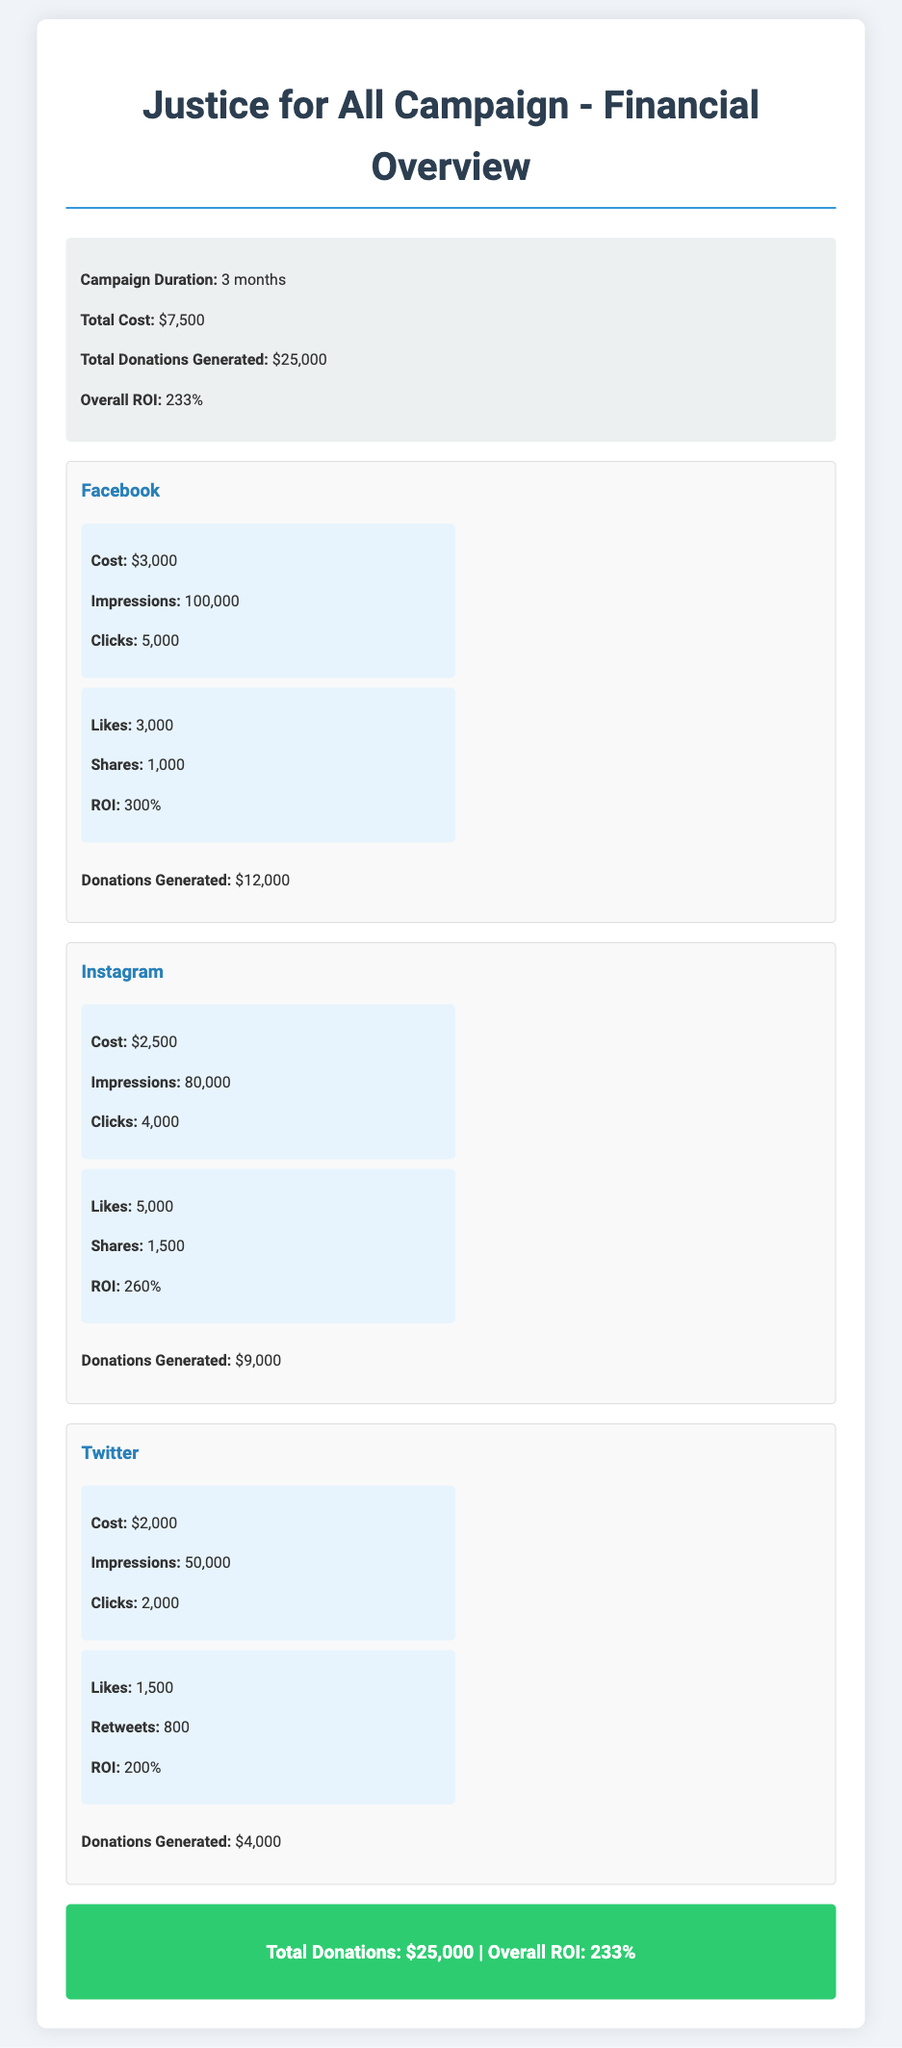What is the total cost of the campaign? The total cost is listed in the summary section of the document as $7,500.
Answer: $7,500 What was the total amount of donations generated? The total donations generated are provided in the summary section as $25,000.
Answer: $25,000 What is the ROI for the Facebook platform? The ROI for Facebook is stated in the metrics section specific to Facebook as 300%.
Answer: 300% How many impressions did the Instagram campaign receive? The number of impressions for Instagram is provided in the metrics section as 80,000.
Answer: 80,000 What is the total of donations generated from Twitter? The donations generated from Twitter are specified in the Twitter platform section as $4,000.
Answer: $4,000 Which platform had the highest cost? The platform with the highest cost is mentioned in the platform sections as Facebook with a cost of $3,000.
Answer: Facebook What is the overall ROI for the campaign? The overall ROI is detailed in the summary section of the document as 233%.
Answer: 233% How many likes did the Instagram campaign receive? The number of likes for the Instagram campaign is specified in the metrics section as 5,000.
Answer: 5,000 What is the duration of the campaign? The duration of the campaign is noted in the summary section as 3 months.
Answer: 3 months 